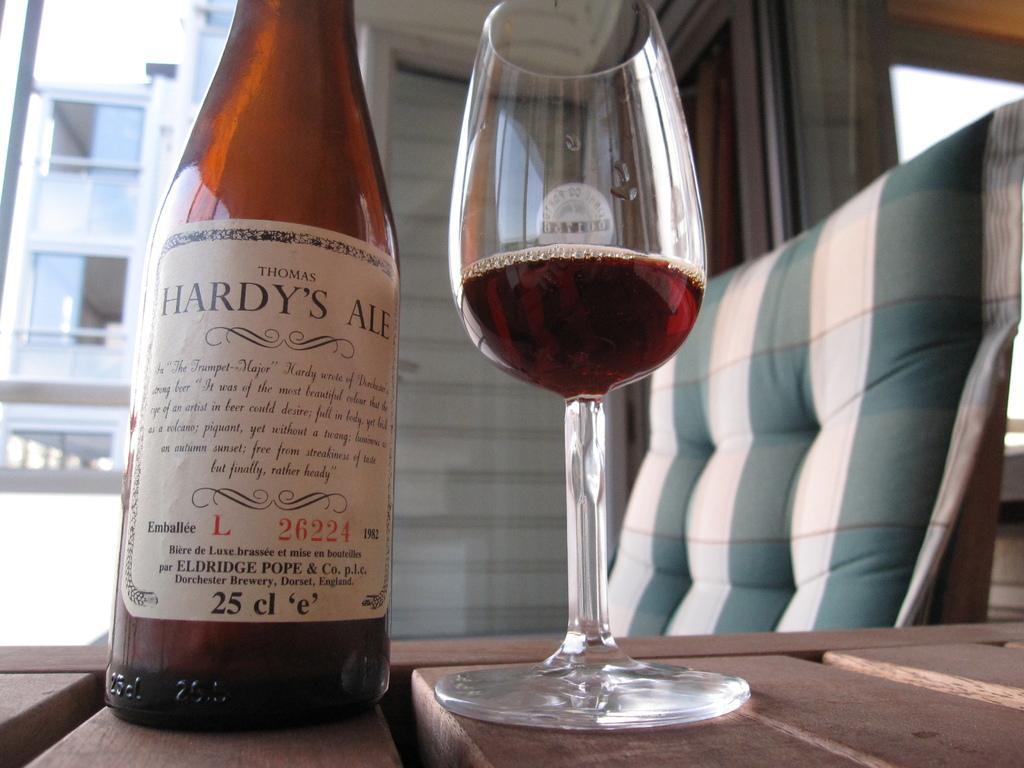Could you give a brief overview of what you see in this image? In the image there is a table. On table we can see a bottle which it is labelled as 'HARDY'S ALE' and a glass with some drink. On right side we can see a couch, on left side there is a building. In middle there is a door which is closed. 